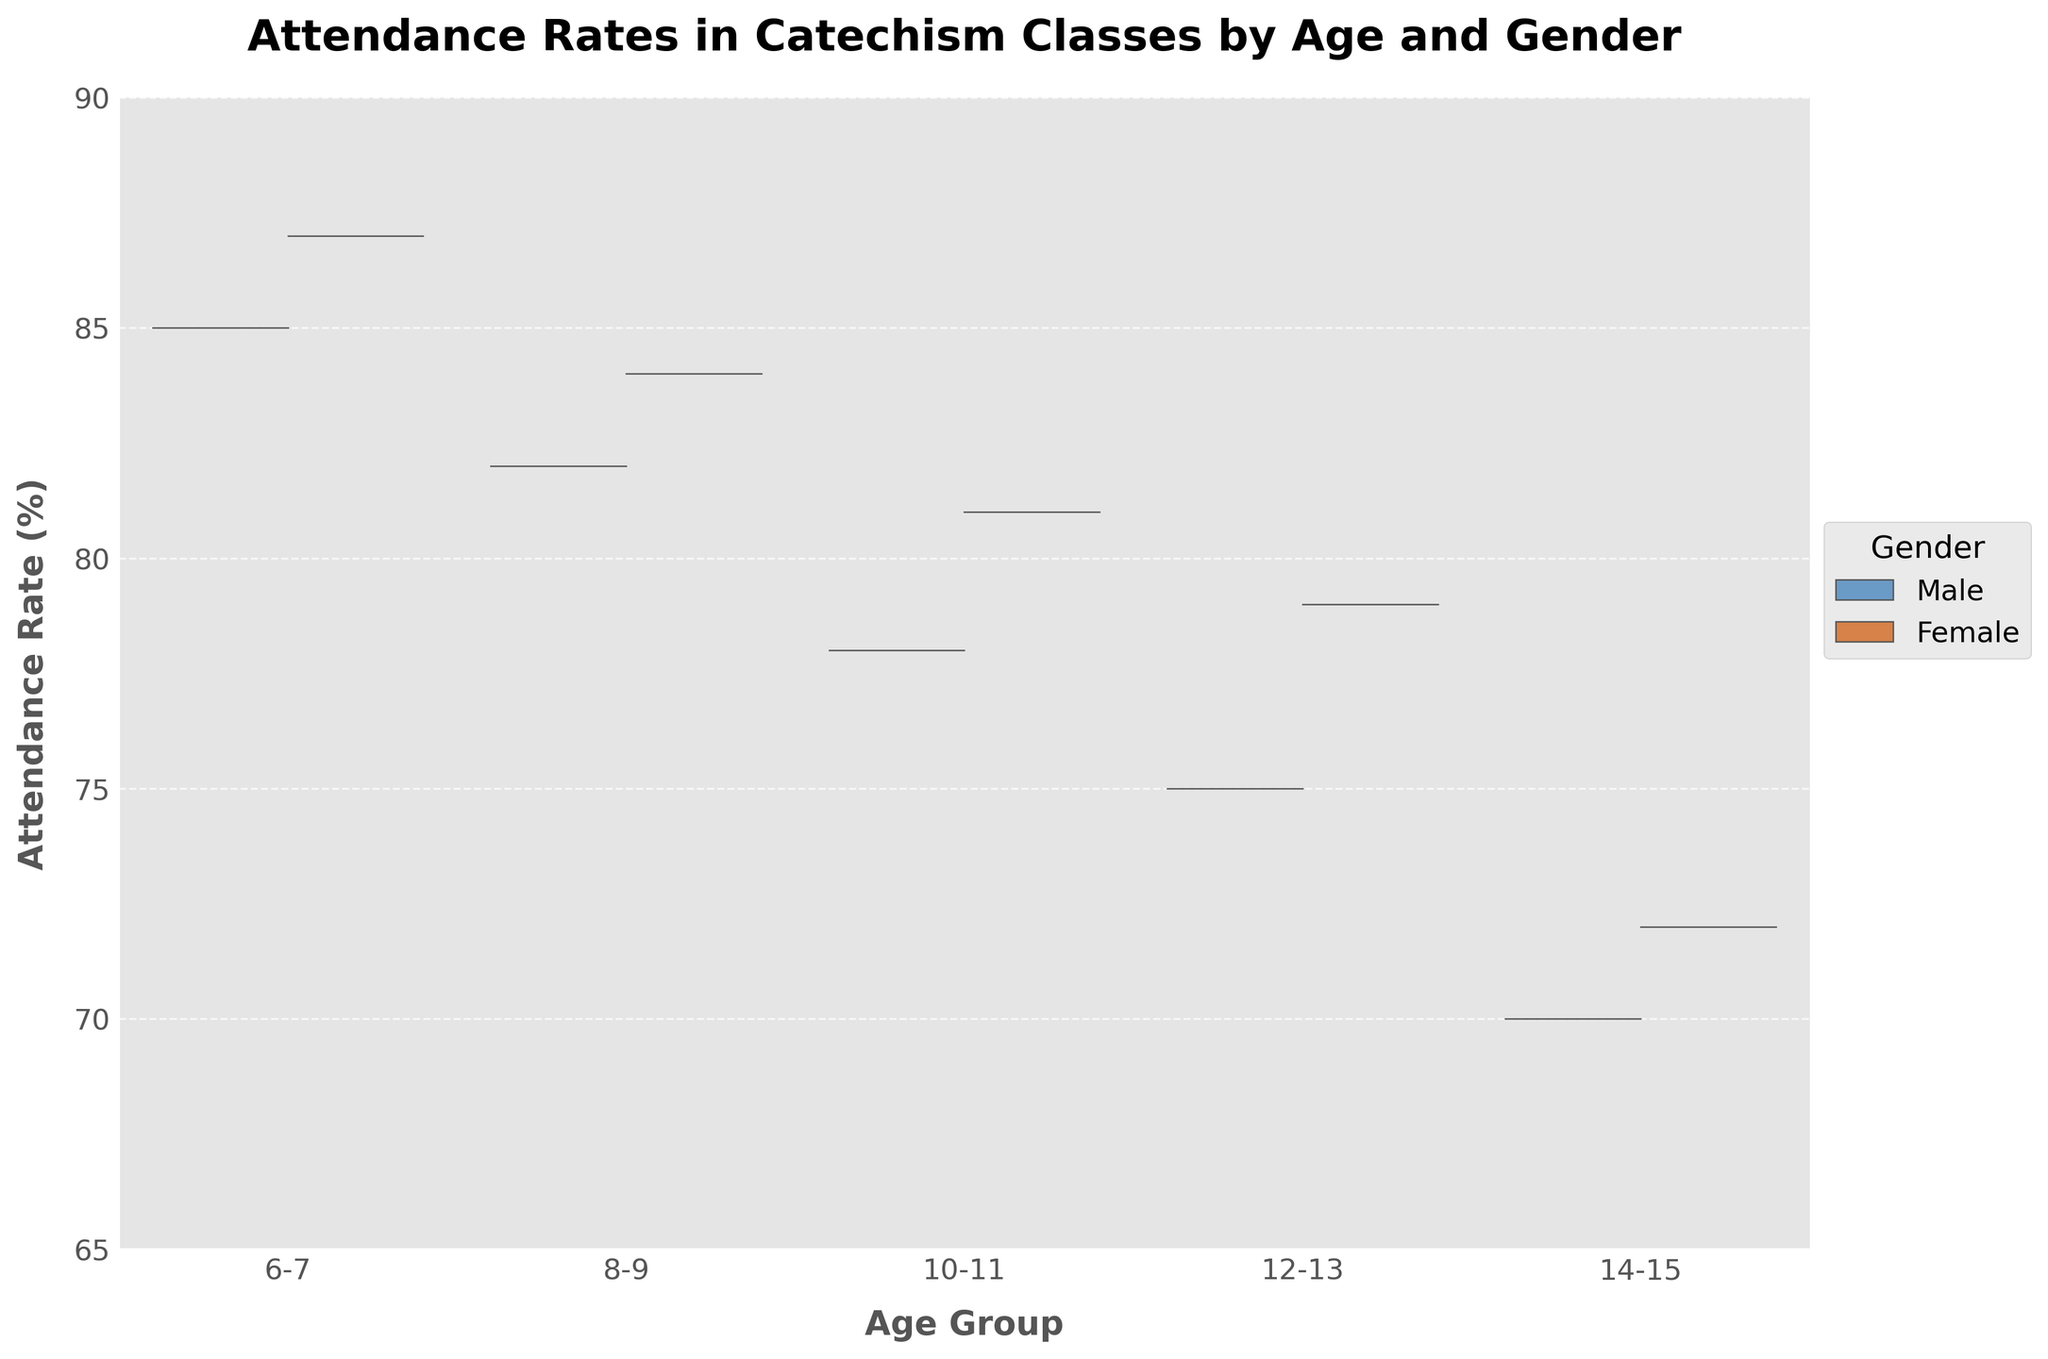What's the title of this chart? The title is located at the top of the figure, usually in bold for emphasis. It provides the overall summary of the chart's subject.
Answer: Attendance Rates in Catechism Classes by Age and Gender Which gender has higher attendance rates in the 6-7 age group? To answer this, we compare the attendance rates of males and females in the 6-7 category.
Answer: Female What's the range of attendance rates displayed on the y-axis? To determine the range, look at the minimum and maximum values on the y-axis.
Answer: 65 to 90 Is there any age group where both genders have equal attendance rates? To find this, we can compare the attendance rates of males and females for each age group.
Answer: No In which age group is the attendance rate of males less than 80%? To solve this, review the attendance rates of males in each age group and see which falls below 80%.
Answer: 10-11, 12-13, 14-15 What's the difference in attendance rates between males and females in the 14-15 age group? Subtract the attendance rate of males from that of females in the 14-15 age group: 72 - 70.
Answer: 2% How do the attendance rates for males change from the 6-7 age group to the 14-15 age group? Compare the attendance rates across each age group for males to see the trend.
Answer: Decrease from 85% to 70% In which age group is the gap between male and female attendance rates the smallest? Calculate the difference between male and female rates for each age group and identify the smallest gap.
Answer: 8-9 How does the attendance trend for females compare to males as age increases? Compare the trend lines for females and males across different age groups to observe if both increase, decrease, or vary differently.
Answer: Both decrease but at different rates What is the average attendance rate for females across all age groups? Sum the attendance rates for females (87, 84, 81, 79, 72) and divide by the number of age groups: (87+84+81+79+72)/5.
Answer: 80.6% 